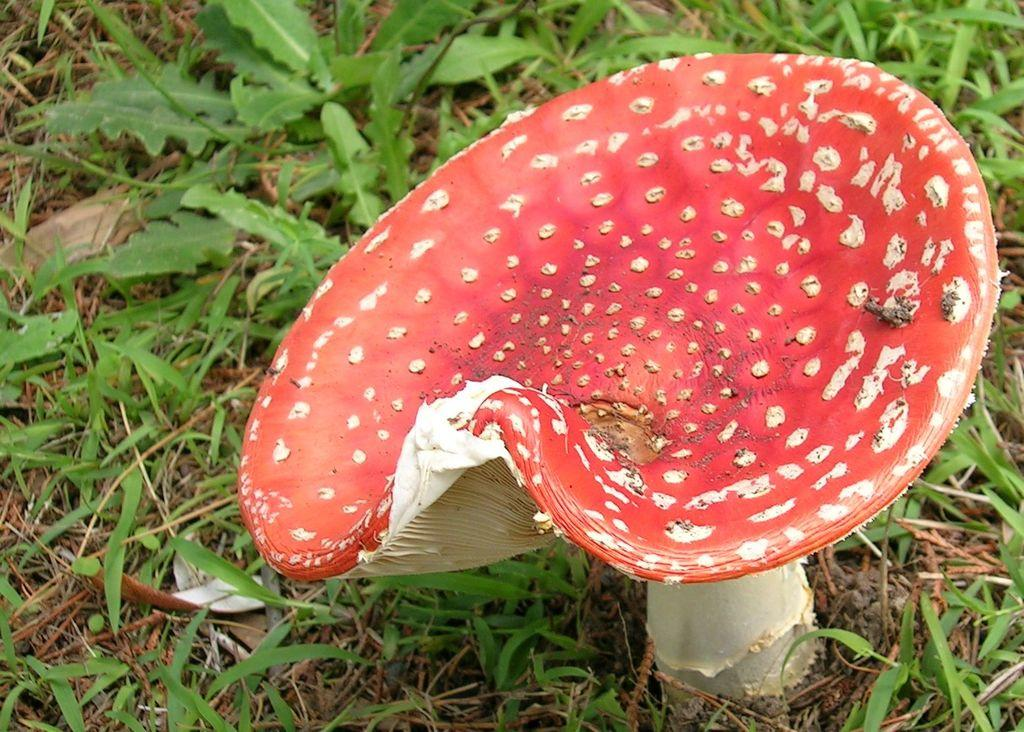What type of mushroom can be seen in the image? The image contains a species of mushroom called fly agaric. What other types of vegetation are present in the image? There are small plants and grass in the image. How many cows are grazing on the grass in the image? There are no cows present in the image; it only features mushrooms, small plants, and grass. What type of flower can be seen among the small plants in the image? There is no flower, specifically a rose, present among the small plants in the image. 